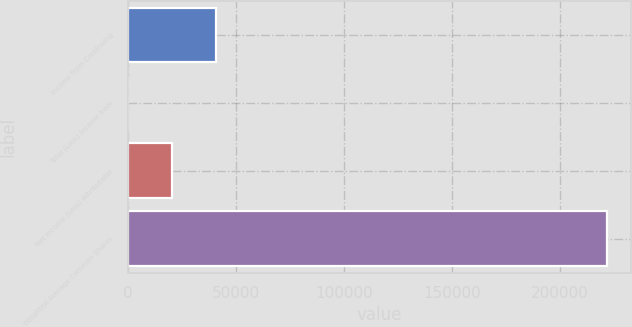Convert chart to OTSL. <chart><loc_0><loc_0><loc_500><loc_500><bar_chart><fcel>Income from Continuing<fcel>Total (Loss) Income from<fcel>Net Income (Loss) Attributable<fcel>Weighted Average Common Shares<nl><fcel>40658.1<fcel>0.07<fcel>20329.1<fcel>221608<nl></chart> 